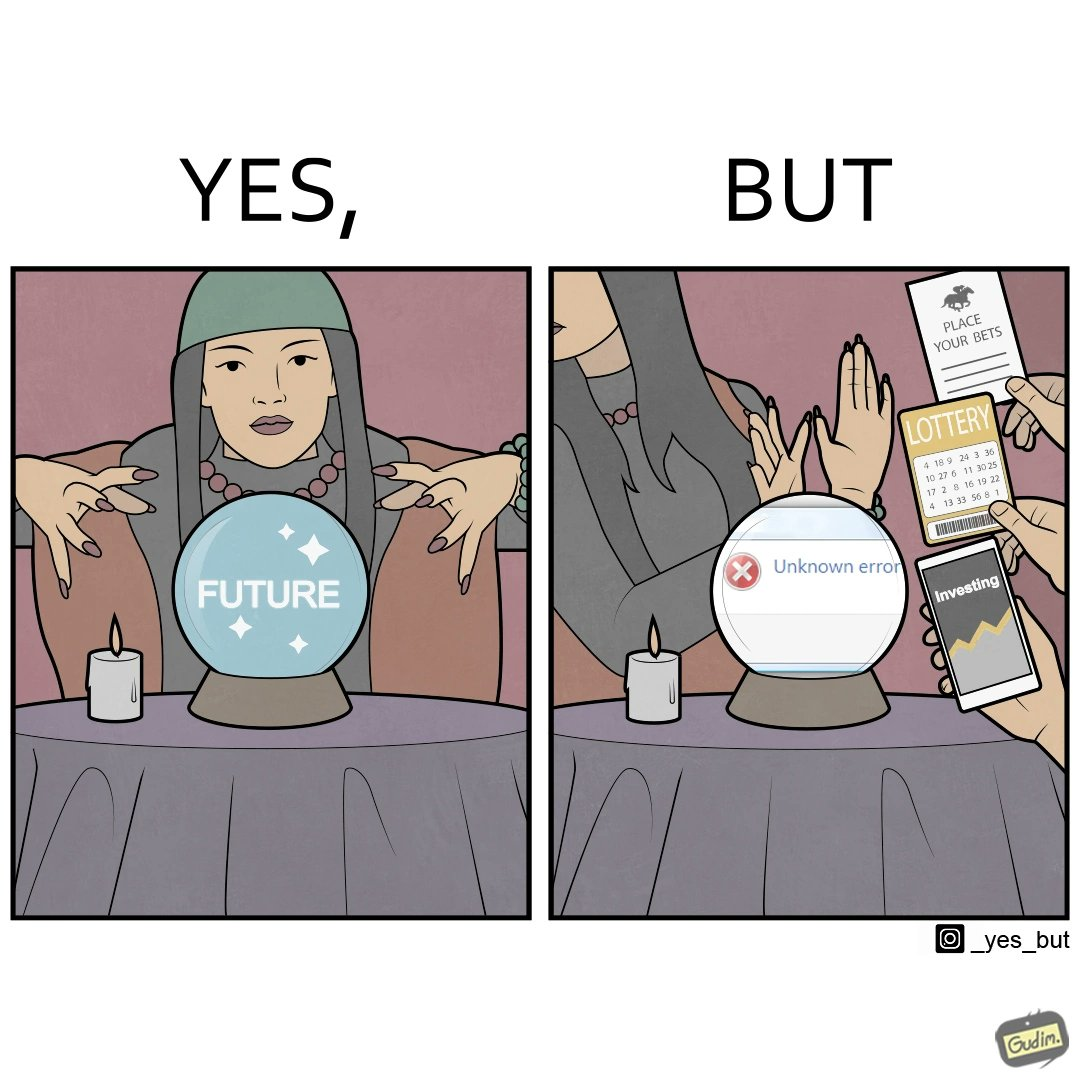Compare the left and right sides of this image. In the left part of the image: a woman dressed up as fortune teller with a candle and a fortune teller globe with "FORTUNE" written on it In the right part of the image: a woman rejecting peoples' request to predict on finance, bets and lottery as giving some "Unknown error" 